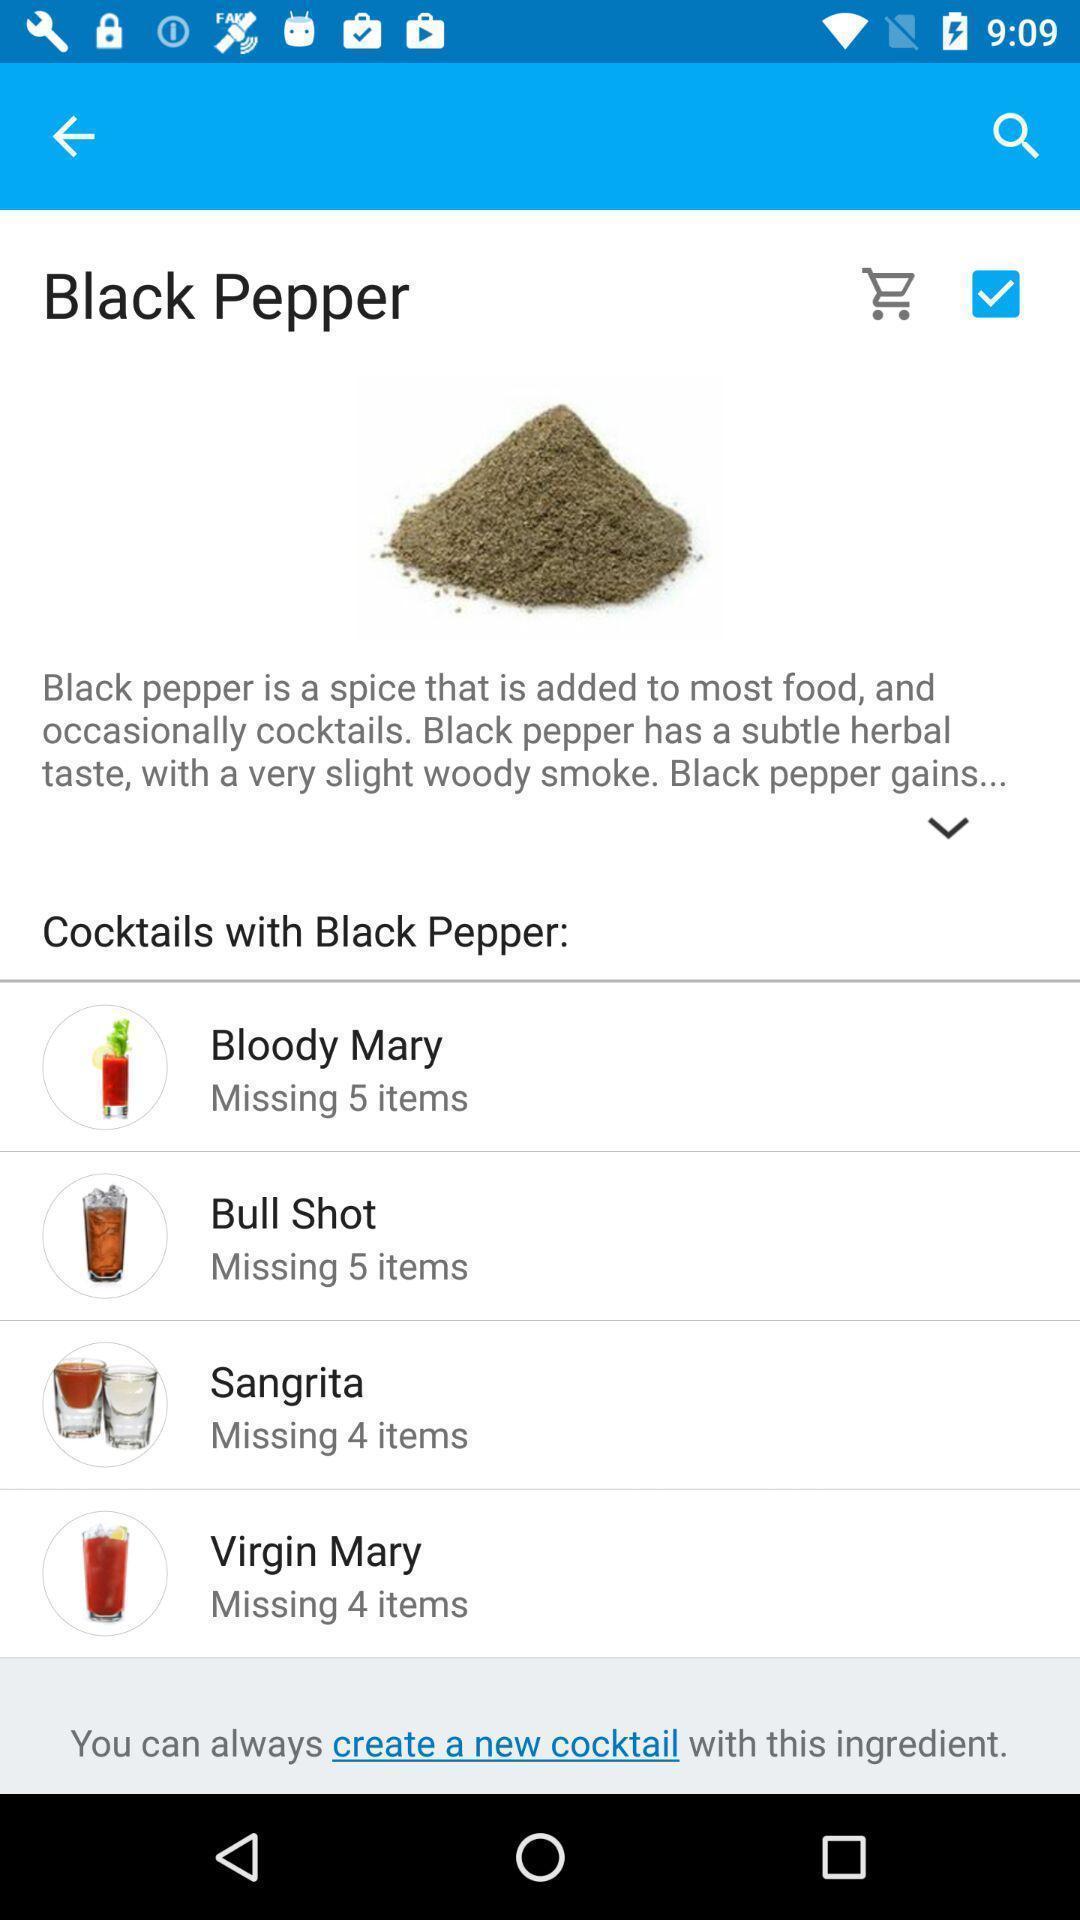Summarize the information in this screenshot. Page displaying cocktails information. 